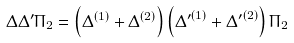Convert formula to latex. <formula><loc_0><loc_0><loc_500><loc_500>\Delta \Delta ^ { \prime } \Pi _ { 2 } = \left ( \Delta ^ { ( 1 ) } + \Delta ^ { ( 2 ) } \right ) \left ( { \Delta ^ { \prime } } ^ { ( 1 ) } + { \Delta ^ { \prime } } ^ { ( 2 ) } \right ) \Pi _ { 2 }</formula> 